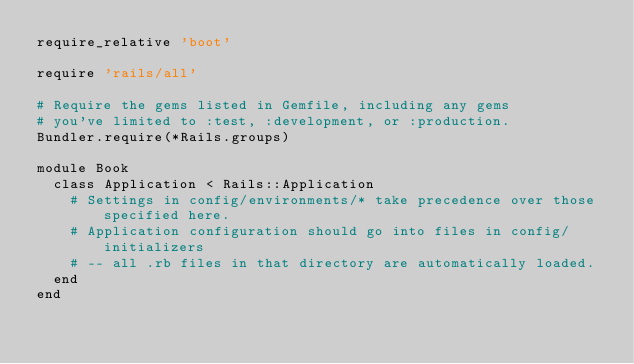<code> <loc_0><loc_0><loc_500><loc_500><_Ruby_>require_relative 'boot'

require 'rails/all'

# Require the gems listed in Gemfile, including any gems
# you've limited to :test, :development, or :production.
Bundler.require(*Rails.groups)

module Book
  class Application < Rails::Application
    # Settings in config/environments/* take precedence over those specified here.
    # Application configuration should go into files in config/initializers
    # -- all .rb files in that directory are automatically loaded.
  end
end
</code> 